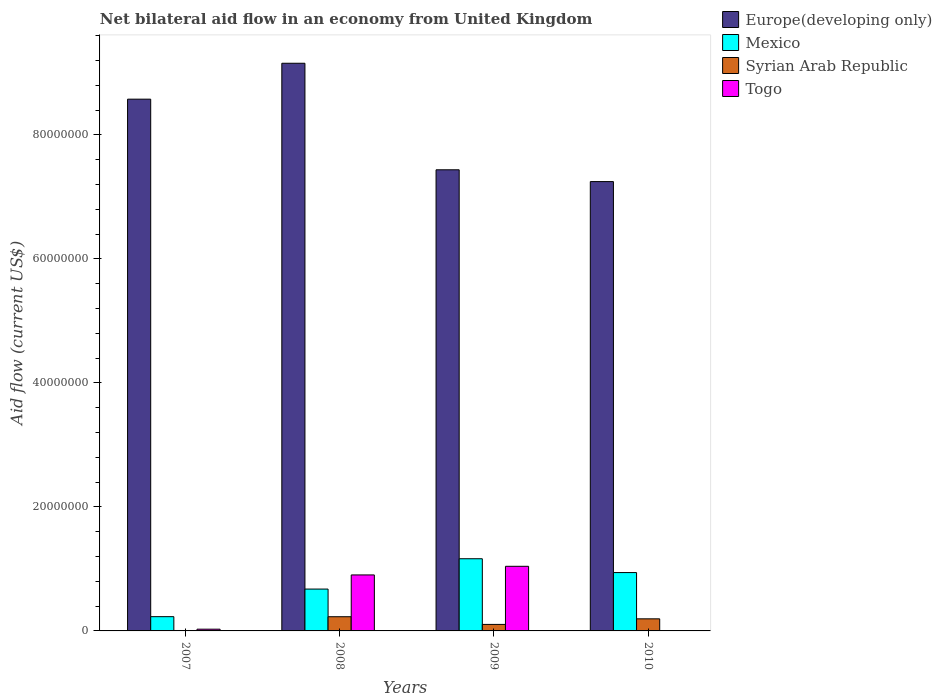Are the number of bars per tick equal to the number of legend labels?
Your answer should be very brief. No. Are the number of bars on each tick of the X-axis equal?
Your answer should be compact. No. How many bars are there on the 3rd tick from the left?
Offer a terse response. 4. What is the label of the 4th group of bars from the left?
Your answer should be very brief. 2010. In how many cases, is the number of bars for a given year not equal to the number of legend labels?
Provide a short and direct response. 1. What is the net bilateral aid flow in Syrian Arab Republic in 2008?
Provide a short and direct response. 2.29e+06. Across all years, what is the maximum net bilateral aid flow in Europe(developing only)?
Offer a terse response. 9.15e+07. Across all years, what is the minimum net bilateral aid flow in Europe(developing only)?
Ensure brevity in your answer.  7.25e+07. What is the total net bilateral aid flow in Togo in the graph?
Provide a short and direct response. 1.97e+07. What is the difference between the net bilateral aid flow in Europe(developing only) in 2007 and that in 2008?
Your response must be concise. -5.79e+06. What is the difference between the net bilateral aid flow in Togo in 2007 and the net bilateral aid flow in Europe(developing only) in 2008?
Make the answer very short. -9.13e+07. What is the average net bilateral aid flow in Europe(developing only) per year?
Your answer should be very brief. 8.10e+07. In the year 2008, what is the difference between the net bilateral aid flow in Togo and net bilateral aid flow in Syrian Arab Republic?
Your response must be concise. 6.74e+06. In how many years, is the net bilateral aid flow in Mexico greater than 88000000 US$?
Offer a terse response. 0. What is the ratio of the net bilateral aid flow in Europe(developing only) in 2007 to that in 2010?
Provide a short and direct response. 1.18. Is the net bilateral aid flow in Europe(developing only) in 2007 less than that in 2008?
Offer a very short reply. Yes. Is the difference between the net bilateral aid flow in Togo in 2007 and 2009 greater than the difference between the net bilateral aid flow in Syrian Arab Republic in 2007 and 2009?
Give a very brief answer. No. What is the difference between the highest and the second highest net bilateral aid flow in Europe(developing only)?
Offer a terse response. 5.79e+06. What is the difference between the highest and the lowest net bilateral aid flow in Togo?
Make the answer very short. 1.04e+07. Is the sum of the net bilateral aid flow in Mexico in 2007 and 2010 greater than the maximum net bilateral aid flow in Togo across all years?
Make the answer very short. Yes. How many bars are there?
Offer a terse response. 15. Are all the bars in the graph horizontal?
Your answer should be compact. No. How many years are there in the graph?
Make the answer very short. 4. What is the difference between two consecutive major ticks on the Y-axis?
Your response must be concise. 2.00e+07. Does the graph contain any zero values?
Make the answer very short. Yes. Where does the legend appear in the graph?
Keep it short and to the point. Top right. What is the title of the graph?
Make the answer very short. Net bilateral aid flow in an economy from United Kingdom. Does "Peru" appear as one of the legend labels in the graph?
Provide a short and direct response. No. What is the Aid flow (current US$) in Europe(developing only) in 2007?
Your answer should be compact. 8.58e+07. What is the Aid flow (current US$) in Mexico in 2007?
Ensure brevity in your answer.  2.30e+06. What is the Aid flow (current US$) of Togo in 2007?
Provide a short and direct response. 2.80e+05. What is the Aid flow (current US$) of Europe(developing only) in 2008?
Provide a succinct answer. 9.15e+07. What is the Aid flow (current US$) of Mexico in 2008?
Your answer should be very brief. 6.75e+06. What is the Aid flow (current US$) in Syrian Arab Republic in 2008?
Your response must be concise. 2.29e+06. What is the Aid flow (current US$) of Togo in 2008?
Your answer should be compact. 9.03e+06. What is the Aid flow (current US$) of Europe(developing only) in 2009?
Ensure brevity in your answer.  7.44e+07. What is the Aid flow (current US$) in Mexico in 2009?
Ensure brevity in your answer.  1.16e+07. What is the Aid flow (current US$) of Syrian Arab Republic in 2009?
Offer a terse response. 1.05e+06. What is the Aid flow (current US$) of Togo in 2009?
Your response must be concise. 1.04e+07. What is the Aid flow (current US$) of Europe(developing only) in 2010?
Ensure brevity in your answer.  7.25e+07. What is the Aid flow (current US$) in Mexico in 2010?
Provide a short and direct response. 9.41e+06. What is the Aid flow (current US$) in Syrian Arab Republic in 2010?
Keep it short and to the point. 1.95e+06. Across all years, what is the maximum Aid flow (current US$) of Europe(developing only)?
Make the answer very short. 9.15e+07. Across all years, what is the maximum Aid flow (current US$) in Mexico?
Your answer should be compact. 1.16e+07. Across all years, what is the maximum Aid flow (current US$) in Syrian Arab Republic?
Provide a succinct answer. 2.29e+06. Across all years, what is the maximum Aid flow (current US$) of Togo?
Ensure brevity in your answer.  1.04e+07. Across all years, what is the minimum Aid flow (current US$) of Europe(developing only)?
Ensure brevity in your answer.  7.25e+07. Across all years, what is the minimum Aid flow (current US$) of Mexico?
Provide a succinct answer. 2.30e+06. What is the total Aid flow (current US$) of Europe(developing only) in the graph?
Your response must be concise. 3.24e+08. What is the total Aid flow (current US$) in Mexico in the graph?
Keep it short and to the point. 3.01e+07. What is the total Aid flow (current US$) in Syrian Arab Republic in the graph?
Provide a short and direct response. 5.36e+06. What is the total Aid flow (current US$) of Togo in the graph?
Provide a succinct answer. 1.97e+07. What is the difference between the Aid flow (current US$) of Europe(developing only) in 2007 and that in 2008?
Keep it short and to the point. -5.79e+06. What is the difference between the Aid flow (current US$) in Mexico in 2007 and that in 2008?
Give a very brief answer. -4.45e+06. What is the difference between the Aid flow (current US$) in Syrian Arab Republic in 2007 and that in 2008?
Offer a very short reply. -2.22e+06. What is the difference between the Aid flow (current US$) in Togo in 2007 and that in 2008?
Keep it short and to the point. -8.75e+06. What is the difference between the Aid flow (current US$) of Europe(developing only) in 2007 and that in 2009?
Offer a very short reply. 1.14e+07. What is the difference between the Aid flow (current US$) of Mexico in 2007 and that in 2009?
Give a very brief answer. -9.34e+06. What is the difference between the Aid flow (current US$) of Syrian Arab Republic in 2007 and that in 2009?
Your answer should be compact. -9.80e+05. What is the difference between the Aid flow (current US$) of Togo in 2007 and that in 2009?
Ensure brevity in your answer.  -1.01e+07. What is the difference between the Aid flow (current US$) in Europe(developing only) in 2007 and that in 2010?
Your answer should be compact. 1.33e+07. What is the difference between the Aid flow (current US$) of Mexico in 2007 and that in 2010?
Provide a short and direct response. -7.11e+06. What is the difference between the Aid flow (current US$) of Syrian Arab Republic in 2007 and that in 2010?
Offer a terse response. -1.88e+06. What is the difference between the Aid flow (current US$) in Europe(developing only) in 2008 and that in 2009?
Give a very brief answer. 1.72e+07. What is the difference between the Aid flow (current US$) in Mexico in 2008 and that in 2009?
Your answer should be very brief. -4.89e+06. What is the difference between the Aid flow (current US$) of Syrian Arab Republic in 2008 and that in 2009?
Your answer should be very brief. 1.24e+06. What is the difference between the Aid flow (current US$) of Togo in 2008 and that in 2009?
Keep it short and to the point. -1.39e+06. What is the difference between the Aid flow (current US$) of Europe(developing only) in 2008 and that in 2010?
Make the answer very short. 1.91e+07. What is the difference between the Aid flow (current US$) in Mexico in 2008 and that in 2010?
Your response must be concise. -2.66e+06. What is the difference between the Aid flow (current US$) of Syrian Arab Republic in 2008 and that in 2010?
Give a very brief answer. 3.40e+05. What is the difference between the Aid flow (current US$) in Europe(developing only) in 2009 and that in 2010?
Make the answer very short. 1.90e+06. What is the difference between the Aid flow (current US$) of Mexico in 2009 and that in 2010?
Keep it short and to the point. 2.23e+06. What is the difference between the Aid flow (current US$) of Syrian Arab Republic in 2009 and that in 2010?
Provide a succinct answer. -9.00e+05. What is the difference between the Aid flow (current US$) of Europe(developing only) in 2007 and the Aid flow (current US$) of Mexico in 2008?
Provide a short and direct response. 7.90e+07. What is the difference between the Aid flow (current US$) in Europe(developing only) in 2007 and the Aid flow (current US$) in Syrian Arab Republic in 2008?
Your answer should be very brief. 8.35e+07. What is the difference between the Aid flow (current US$) in Europe(developing only) in 2007 and the Aid flow (current US$) in Togo in 2008?
Give a very brief answer. 7.67e+07. What is the difference between the Aid flow (current US$) in Mexico in 2007 and the Aid flow (current US$) in Syrian Arab Republic in 2008?
Your response must be concise. 10000. What is the difference between the Aid flow (current US$) in Mexico in 2007 and the Aid flow (current US$) in Togo in 2008?
Your answer should be compact. -6.73e+06. What is the difference between the Aid flow (current US$) in Syrian Arab Republic in 2007 and the Aid flow (current US$) in Togo in 2008?
Make the answer very short. -8.96e+06. What is the difference between the Aid flow (current US$) of Europe(developing only) in 2007 and the Aid flow (current US$) of Mexico in 2009?
Your answer should be very brief. 7.41e+07. What is the difference between the Aid flow (current US$) in Europe(developing only) in 2007 and the Aid flow (current US$) in Syrian Arab Republic in 2009?
Your answer should be compact. 8.47e+07. What is the difference between the Aid flow (current US$) of Europe(developing only) in 2007 and the Aid flow (current US$) of Togo in 2009?
Your answer should be compact. 7.53e+07. What is the difference between the Aid flow (current US$) of Mexico in 2007 and the Aid flow (current US$) of Syrian Arab Republic in 2009?
Offer a very short reply. 1.25e+06. What is the difference between the Aid flow (current US$) in Mexico in 2007 and the Aid flow (current US$) in Togo in 2009?
Your response must be concise. -8.12e+06. What is the difference between the Aid flow (current US$) in Syrian Arab Republic in 2007 and the Aid flow (current US$) in Togo in 2009?
Your answer should be very brief. -1.04e+07. What is the difference between the Aid flow (current US$) in Europe(developing only) in 2007 and the Aid flow (current US$) in Mexico in 2010?
Provide a succinct answer. 7.63e+07. What is the difference between the Aid flow (current US$) of Europe(developing only) in 2007 and the Aid flow (current US$) of Syrian Arab Republic in 2010?
Offer a terse response. 8.38e+07. What is the difference between the Aid flow (current US$) in Europe(developing only) in 2008 and the Aid flow (current US$) in Mexico in 2009?
Your answer should be compact. 7.99e+07. What is the difference between the Aid flow (current US$) of Europe(developing only) in 2008 and the Aid flow (current US$) of Syrian Arab Republic in 2009?
Provide a succinct answer. 9.05e+07. What is the difference between the Aid flow (current US$) of Europe(developing only) in 2008 and the Aid flow (current US$) of Togo in 2009?
Keep it short and to the point. 8.11e+07. What is the difference between the Aid flow (current US$) in Mexico in 2008 and the Aid flow (current US$) in Syrian Arab Republic in 2009?
Give a very brief answer. 5.70e+06. What is the difference between the Aid flow (current US$) in Mexico in 2008 and the Aid flow (current US$) in Togo in 2009?
Make the answer very short. -3.67e+06. What is the difference between the Aid flow (current US$) of Syrian Arab Republic in 2008 and the Aid flow (current US$) of Togo in 2009?
Keep it short and to the point. -8.13e+06. What is the difference between the Aid flow (current US$) of Europe(developing only) in 2008 and the Aid flow (current US$) of Mexico in 2010?
Your answer should be very brief. 8.21e+07. What is the difference between the Aid flow (current US$) of Europe(developing only) in 2008 and the Aid flow (current US$) of Syrian Arab Republic in 2010?
Provide a short and direct response. 8.96e+07. What is the difference between the Aid flow (current US$) of Mexico in 2008 and the Aid flow (current US$) of Syrian Arab Republic in 2010?
Your response must be concise. 4.80e+06. What is the difference between the Aid flow (current US$) of Europe(developing only) in 2009 and the Aid flow (current US$) of Mexico in 2010?
Provide a succinct answer. 6.50e+07. What is the difference between the Aid flow (current US$) of Europe(developing only) in 2009 and the Aid flow (current US$) of Syrian Arab Republic in 2010?
Ensure brevity in your answer.  7.24e+07. What is the difference between the Aid flow (current US$) in Mexico in 2009 and the Aid flow (current US$) in Syrian Arab Republic in 2010?
Offer a terse response. 9.69e+06. What is the average Aid flow (current US$) of Europe(developing only) per year?
Your response must be concise. 8.10e+07. What is the average Aid flow (current US$) in Mexico per year?
Your answer should be compact. 7.52e+06. What is the average Aid flow (current US$) in Syrian Arab Republic per year?
Offer a very short reply. 1.34e+06. What is the average Aid flow (current US$) in Togo per year?
Offer a very short reply. 4.93e+06. In the year 2007, what is the difference between the Aid flow (current US$) of Europe(developing only) and Aid flow (current US$) of Mexico?
Offer a very short reply. 8.34e+07. In the year 2007, what is the difference between the Aid flow (current US$) of Europe(developing only) and Aid flow (current US$) of Syrian Arab Republic?
Your response must be concise. 8.57e+07. In the year 2007, what is the difference between the Aid flow (current US$) in Europe(developing only) and Aid flow (current US$) in Togo?
Give a very brief answer. 8.55e+07. In the year 2007, what is the difference between the Aid flow (current US$) of Mexico and Aid flow (current US$) of Syrian Arab Republic?
Your answer should be compact. 2.23e+06. In the year 2007, what is the difference between the Aid flow (current US$) of Mexico and Aid flow (current US$) of Togo?
Keep it short and to the point. 2.02e+06. In the year 2008, what is the difference between the Aid flow (current US$) in Europe(developing only) and Aid flow (current US$) in Mexico?
Your response must be concise. 8.48e+07. In the year 2008, what is the difference between the Aid flow (current US$) of Europe(developing only) and Aid flow (current US$) of Syrian Arab Republic?
Give a very brief answer. 8.92e+07. In the year 2008, what is the difference between the Aid flow (current US$) in Europe(developing only) and Aid flow (current US$) in Togo?
Keep it short and to the point. 8.25e+07. In the year 2008, what is the difference between the Aid flow (current US$) in Mexico and Aid flow (current US$) in Syrian Arab Republic?
Provide a succinct answer. 4.46e+06. In the year 2008, what is the difference between the Aid flow (current US$) of Mexico and Aid flow (current US$) of Togo?
Offer a very short reply. -2.28e+06. In the year 2008, what is the difference between the Aid flow (current US$) in Syrian Arab Republic and Aid flow (current US$) in Togo?
Keep it short and to the point. -6.74e+06. In the year 2009, what is the difference between the Aid flow (current US$) in Europe(developing only) and Aid flow (current US$) in Mexico?
Keep it short and to the point. 6.27e+07. In the year 2009, what is the difference between the Aid flow (current US$) of Europe(developing only) and Aid flow (current US$) of Syrian Arab Republic?
Your answer should be very brief. 7.33e+07. In the year 2009, what is the difference between the Aid flow (current US$) of Europe(developing only) and Aid flow (current US$) of Togo?
Give a very brief answer. 6.39e+07. In the year 2009, what is the difference between the Aid flow (current US$) of Mexico and Aid flow (current US$) of Syrian Arab Republic?
Make the answer very short. 1.06e+07. In the year 2009, what is the difference between the Aid flow (current US$) of Mexico and Aid flow (current US$) of Togo?
Provide a short and direct response. 1.22e+06. In the year 2009, what is the difference between the Aid flow (current US$) in Syrian Arab Republic and Aid flow (current US$) in Togo?
Keep it short and to the point. -9.37e+06. In the year 2010, what is the difference between the Aid flow (current US$) of Europe(developing only) and Aid flow (current US$) of Mexico?
Ensure brevity in your answer.  6.30e+07. In the year 2010, what is the difference between the Aid flow (current US$) in Europe(developing only) and Aid flow (current US$) in Syrian Arab Republic?
Ensure brevity in your answer.  7.05e+07. In the year 2010, what is the difference between the Aid flow (current US$) in Mexico and Aid flow (current US$) in Syrian Arab Republic?
Your answer should be very brief. 7.46e+06. What is the ratio of the Aid flow (current US$) in Europe(developing only) in 2007 to that in 2008?
Ensure brevity in your answer.  0.94. What is the ratio of the Aid flow (current US$) of Mexico in 2007 to that in 2008?
Offer a very short reply. 0.34. What is the ratio of the Aid flow (current US$) in Syrian Arab Republic in 2007 to that in 2008?
Your response must be concise. 0.03. What is the ratio of the Aid flow (current US$) in Togo in 2007 to that in 2008?
Offer a terse response. 0.03. What is the ratio of the Aid flow (current US$) of Europe(developing only) in 2007 to that in 2009?
Give a very brief answer. 1.15. What is the ratio of the Aid flow (current US$) of Mexico in 2007 to that in 2009?
Ensure brevity in your answer.  0.2. What is the ratio of the Aid flow (current US$) in Syrian Arab Republic in 2007 to that in 2009?
Provide a short and direct response. 0.07. What is the ratio of the Aid flow (current US$) of Togo in 2007 to that in 2009?
Provide a short and direct response. 0.03. What is the ratio of the Aid flow (current US$) of Europe(developing only) in 2007 to that in 2010?
Ensure brevity in your answer.  1.18. What is the ratio of the Aid flow (current US$) of Mexico in 2007 to that in 2010?
Your answer should be compact. 0.24. What is the ratio of the Aid flow (current US$) in Syrian Arab Republic in 2007 to that in 2010?
Give a very brief answer. 0.04. What is the ratio of the Aid flow (current US$) in Europe(developing only) in 2008 to that in 2009?
Your answer should be very brief. 1.23. What is the ratio of the Aid flow (current US$) in Mexico in 2008 to that in 2009?
Make the answer very short. 0.58. What is the ratio of the Aid flow (current US$) in Syrian Arab Republic in 2008 to that in 2009?
Your response must be concise. 2.18. What is the ratio of the Aid flow (current US$) of Togo in 2008 to that in 2009?
Your answer should be compact. 0.87. What is the ratio of the Aid flow (current US$) of Europe(developing only) in 2008 to that in 2010?
Offer a terse response. 1.26. What is the ratio of the Aid flow (current US$) in Mexico in 2008 to that in 2010?
Your answer should be compact. 0.72. What is the ratio of the Aid flow (current US$) of Syrian Arab Republic in 2008 to that in 2010?
Your answer should be very brief. 1.17. What is the ratio of the Aid flow (current US$) in Europe(developing only) in 2009 to that in 2010?
Offer a very short reply. 1.03. What is the ratio of the Aid flow (current US$) in Mexico in 2009 to that in 2010?
Offer a terse response. 1.24. What is the ratio of the Aid flow (current US$) in Syrian Arab Republic in 2009 to that in 2010?
Your answer should be very brief. 0.54. What is the difference between the highest and the second highest Aid flow (current US$) of Europe(developing only)?
Your response must be concise. 5.79e+06. What is the difference between the highest and the second highest Aid flow (current US$) in Mexico?
Give a very brief answer. 2.23e+06. What is the difference between the highest and the second highest Aid flow (current US$) in Togo?
Offer a terse response. 1.39e+06. What is the difference between the highest and the lowest Aid flow (current US$) in Europe(developing only)?
Keep it short and to the point. 1.91e+07. What is the difference between the highest and the lowest Aid flow (current US$) in Mexico?
Your answer should be compact. 9.34e+06. What is the difference between the highest and the lowest Aid flow (current US$) in Syrian Arab Republic?
Ensure brevity in your answer.  2.22e+06. What is the difference between the highest and the lowest Aid flow (current US$) of Togo?
Offer a very short reply. 1.04e+07. 